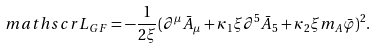<formula> <loc_0><loc_0><loc_500><loc_500>\ m a t h s c r { L } _ { G F } = - \frac { 1 } { 2 \xi } ( \partial ^ { \mu } \bar { A } _ { \mu } + \kappa _ { 1 } \xi \partial ^ { 5 } \bar { A } _ { 5 } + \kappa _ { 2 } \xi m _ { A } \bar { \varphi } ) ^ { 2 } .</formula> 